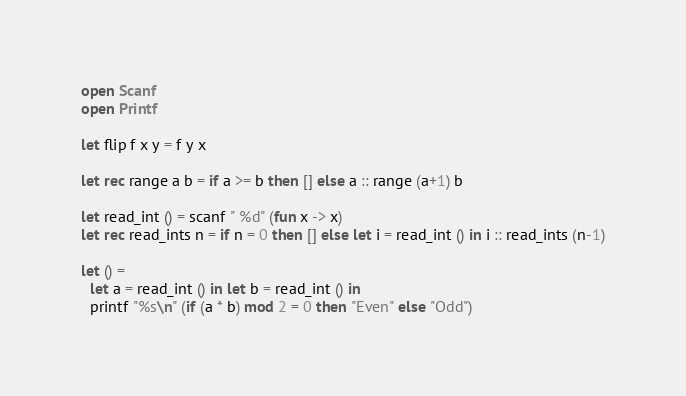<code> <loc_0><loc_0><loc_500><loc_500><_OCaml_>
open Scanf
open Printf

let flip f x y = f y x

let rec range a b = if a >= b then [] else a :: range (a+1) b

let read_int () = scanf " %d" (fun x -> x)
let rec read_ints n = if n = 0 then [] else let i = read_int () in i :: read_ints (n-1)

let () =
  let a = read_int () in let b = read_int () in
  printf "%s\n" (if (a * b) mod 2 = 0 then "Even" else "Odd")
</code> 